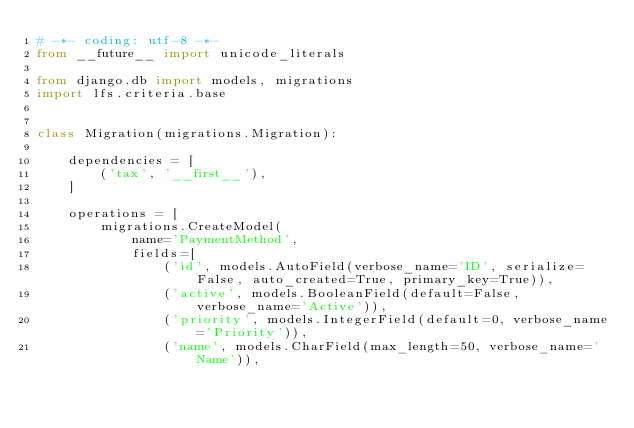Convert code to text. <code><loc_0><loc_0><loc_500><loc_500><_Python_># -*- coding: utf-8 -*-
from __future__ import unicode_literals

from django.db import models, migrations
import lfs.criteria.base


class Migration(migrations.Migration):

    dependencies = [
        ('tax', '__first__'),
    ]

    operations = [
        migrations.CreateModel(
            name='PaymentMethod',
            fields=[
                ('id', models.AutoField(verbose_name='ID', serialize=False, auto_created=True, primary_key=True)),
                ('active', models.BooleanField(default=False, verbose_name='Active')),
                ('priority', models.IntegerField(default=0, verbose_name='Priority')),
                ('name', models.CharField(max_length=50, verbose_name='Name')),</code> 